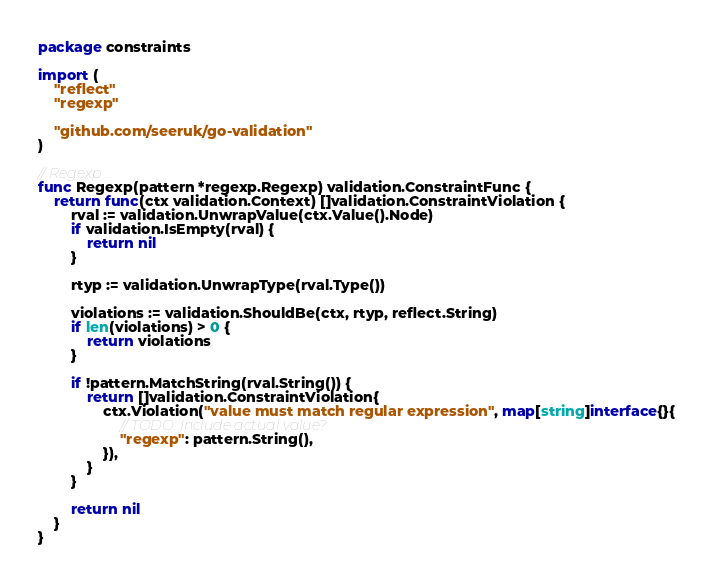<code> <loc_0><loc_0><loc_500><loc_500><_Go_>package constraints

import (
	"reflect"
	"regexp"

	"github.com/seeruk/go-validation"
)

// Regexp ...
func Regexp(pattern *regexp.Regexp) validation.ConstraintFunc {
	return func(ctx validation.Context) []validation.ConstraintViolation {
		rval := validation.UnwrapValue(ctx.Value().Node)
		if validation.IsEmpty(rval) {
			return nil
		}

		rtyp := validation.UnwrapType(rval.Type())

		violations := validation.ShouldBe(ctx, rtyp, reflect.String)
		if len(violations) > 0 {
			return violations
		}

		if !pattern.MatchString(rval.String()) {
			return []validation.ConstraintViolation{
				ctx.Violation("value must match regular expression", map[string]interface{}{
					// TODO: Include actual value?
					"regexp": pattern.String(),
				}),
			}
		}

		return nil
	}
}
</code> 